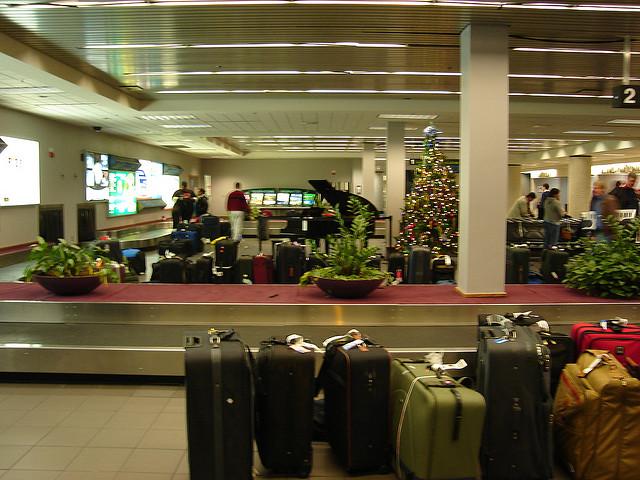What season is it?
Be succinct. Christmas. What musical instrument is in the area?
Concise answer only. Piano. Is this baggage that hasn't been picked up?
Write a very short answer. Yes. 